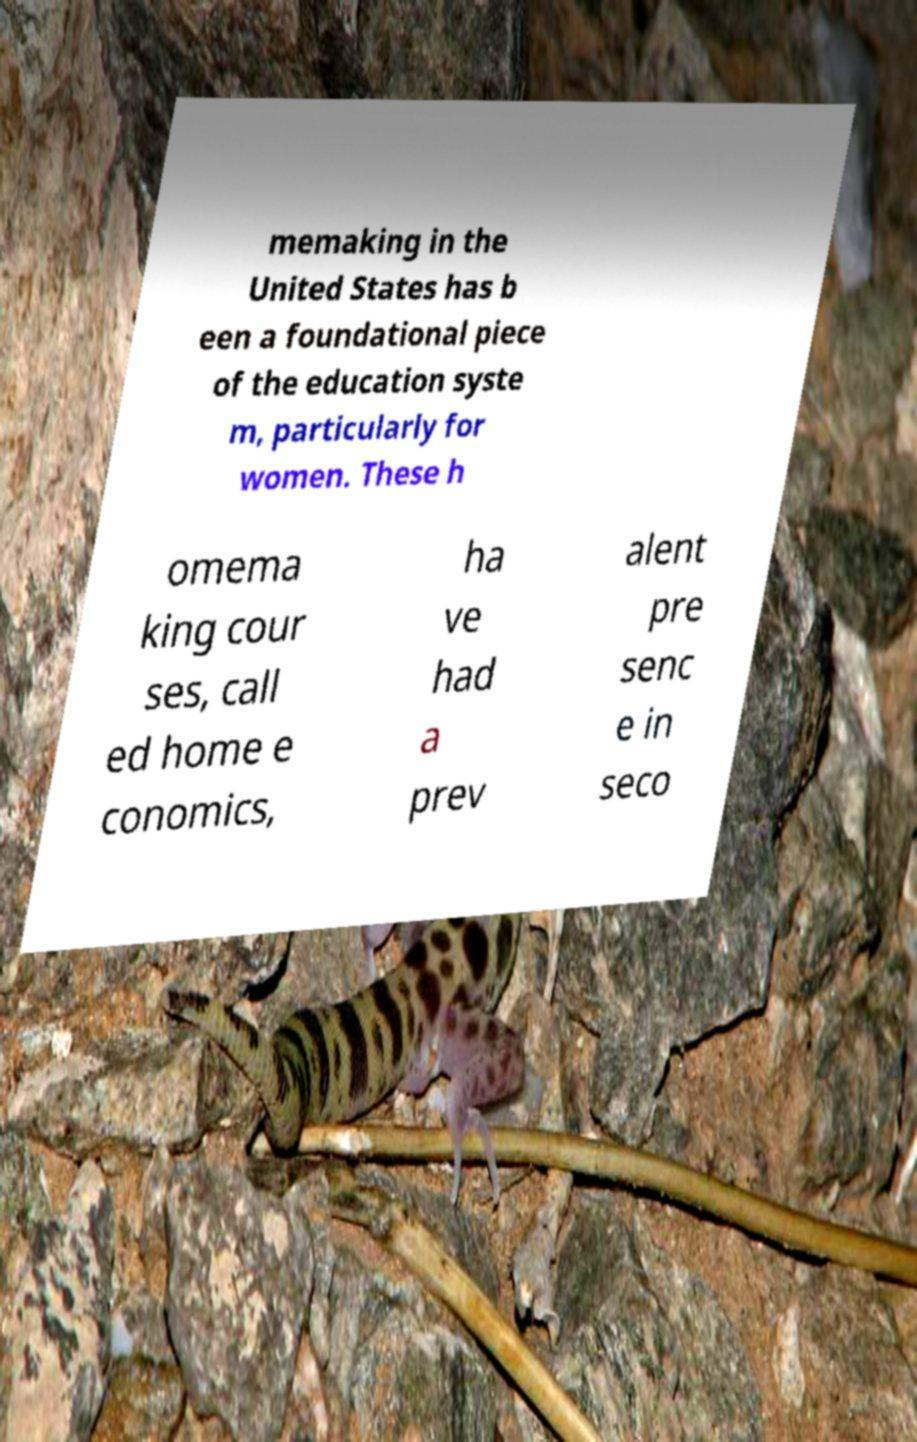Can you accurately transcribe the text from the provided image for me? memaking in the United States has b een a foundational piece of the education syste m, particularly for women. These h omema king cour ses, call ed home e conomics, ha ve had a prev alent pre senc e in seco 